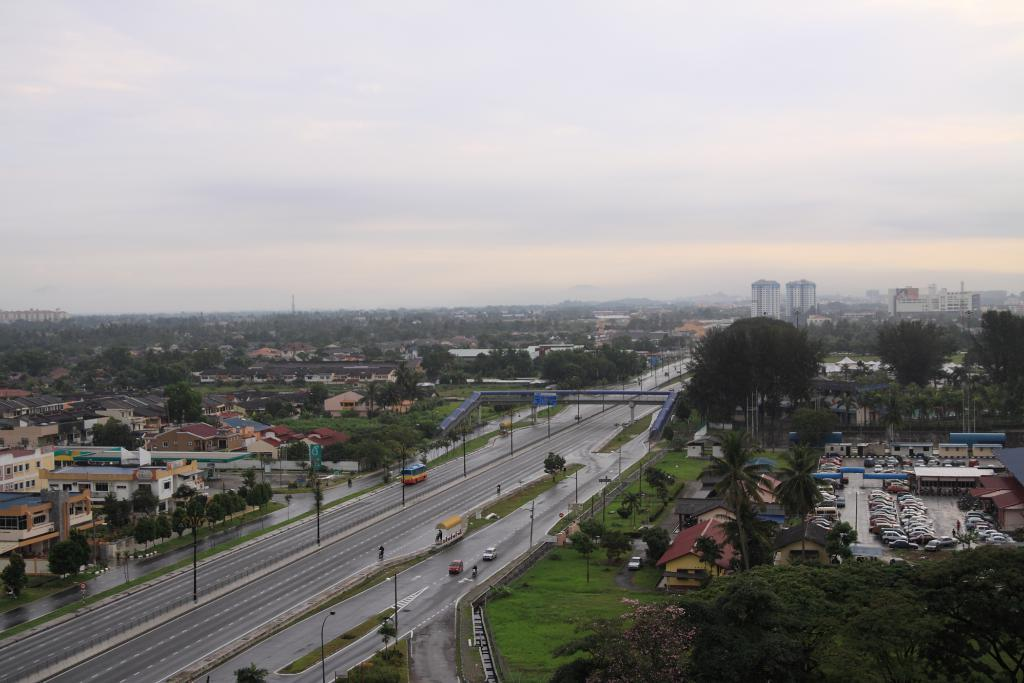What type of structures can be seen in the image? There are buildings in the image. What other natural elements are present in the image? There are trees in the image. What type of man-made paths are visible in the image? There are roads in the image. What vehicles can be seen on the roads? There are cars in the image. Where are the cars located in the image? The cars are at the bottom of the image. What can be seen in the background of the image? The sky is visible in the background of the image. What type of organization is depicted in the image? There is no organization depicted in the image; it features buildings, trees, roads, cars, and the sky. Can you tell me how many cannons are present in the image? There are no cannons present in the image. 